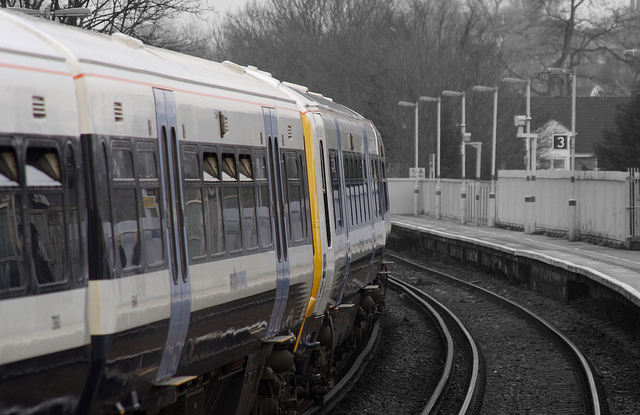Please identify all text content in this image. 3 